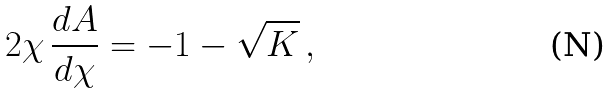Convert formula to latex. <formula><loc_0><loc_0><loc_500><loc_500>2 \chi \, \frac { d A } { d \chi } = - 1 - \sqrt { K } \, ,</formula> 